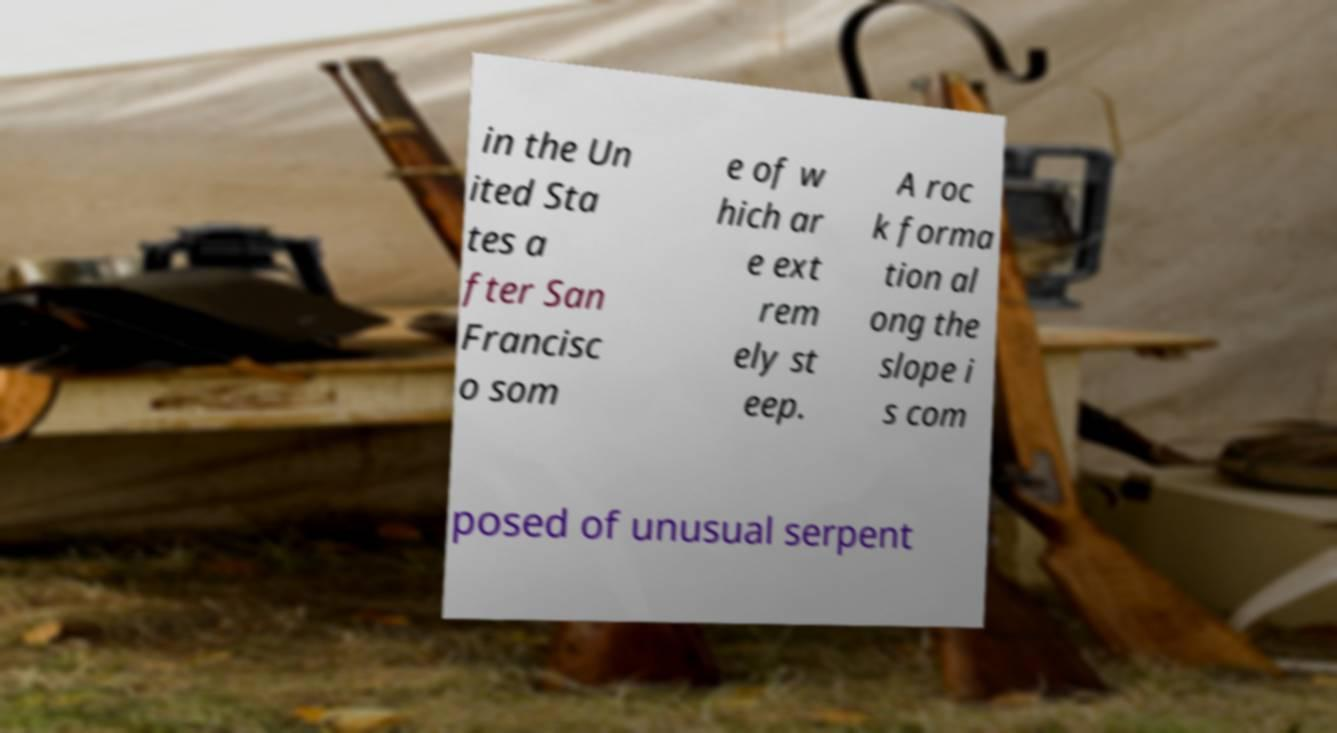Can you read and provide the text displayed in the image?This photo seems to have some interesting text. Can you extract and type it out for me? in the Un ited Sta tes a fter San Francisc o som e of w hich ar e ext rem ely st eep. A roc k forma tion al ong the slope i s com posed of unusual serpent 